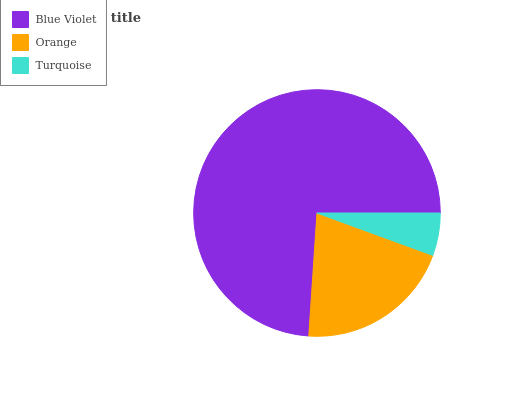Is Turquoise the minimum?
Answer yes or no. Yes. Is Blue Violet the maximum?
Answer yes or no. Yes. Is Orange the minimum?
Answer yes or no. No. Is Orange the maximum?
Answer yes or no. No. Is Blue Violet greater than Orange?
Answer yes or no. Yes. Is Orange less than Blue Violet?
Answer yes or no. Yes. Is Orange greater than Blue Violet?
Answer yes or no. No. Is Blue Violet less than Orange?
Answer yes or no. No. Is Orange the high median?
Answer yes or no. Yes. Is Orange the low median?
Answer yes or no. Yes. Is Turquoise the high median?
Answer yes or no. No. Is Turquoise the low median?
Answer yes or no. No. 